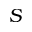<formula> <loc_0><loc_0><loc_500><loc_500>S</formula> 